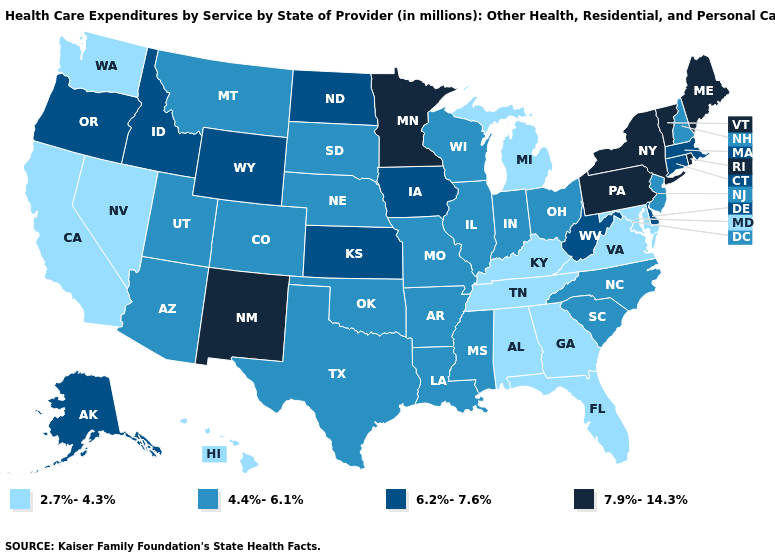Does Michigan have a lower value than Georgia?
Answer briefly. No. Does New Jersey have the highest value in the USA?
Short answer required. No. What is the value of Montana?
Give a very brief answer. 4.4%-6.1%. Name the states that have a value in the range 4.4%-6.1%?
Short answer required. Arizona, Arkansas, Colorado, Illinois, Indiana, Louisiana, Mississippi, Missouri, Montana, Nebraska, New Hampshire, New Jersey, North Carolina, Ohio, Oklahoma, South Carolina, South Dakota, Texas, Utah, Wisconsin. What is the value of Wyoming?
Give a very brief answer. 6.2%-7.6%. What is the value of Nebraska?
Concise answer only. 4.4%-6.1%. Among the states that border Missouri , does Oklahoma have the highest value?
Quick response, please. No. Does Kentucky have the lowest value in the South?
Concise answer only. Yes. Does the map have missing data?
Keep it brief. No. How many symbols are there in the legend?
Answer briefly. 4. Name the states that have a value in the range 4.4%-6.1%?
Answer briefly. Arizona, Arkansas, Colorado, Illinois, Indiana, Louisiana, Mississippi, Missouri, Montana, Nebraska, New Hampshire, New Jersey, North Carolina, Ohio, Oklahoma, South Carolina, South Dakota, Texas, Utah, Wisconsin. Name the states that have a value in the range 7.9%-14.3%?
Quick response, please. Maine, Minnesota, New Mexico, New York, Pennsylvania, Rhode Island, Vermont. Among the states that border Vermont , does Massachusetts have the highest value?
Quick response, please. No. Which states hav the highest value in the Northeast?
Keep it brief. Maine, New York, Pennsylvania, Rhode Island, Vermont. What is the lowest value in the USA?
Keep it brief. 2.7%-4.3%. 